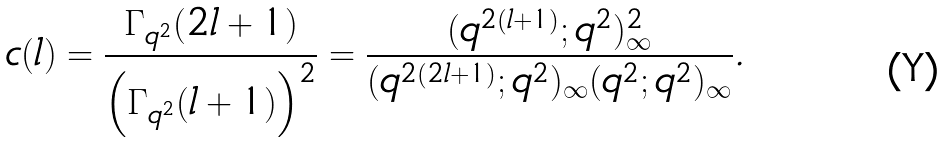<formula> <loc_0><loc_0><loc_500><loc_500>c ( l ) = \frac { \Gamma _ { q ^ { 2 } } ( 2 l + 1 ) } { \left ( \Gamma _ { q ^ { 2 } } ( l + 1 ) \right ) ^ { 2 } } = \frac { ( q ^ { 2 ( l + 1 ) } ; q ^ { 2 } ) _ { \infty } ^ { 2 } } { ( q ^ { 2 ( 2 l + 1 ) } ; q ^ { 2 } ) _ { \infty } ( q ^ { 2 } ; q ^ { 2 } ) _ { \infty } } .</formula> 